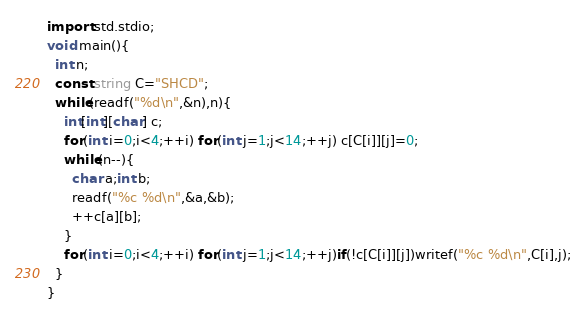Convert code to text. <code><loc_0><loc_0><loc_500><loc_500><_D_>import std.stdio;
void main(){
  int n;
  const string C="SHCD";
  while(readf("%d\n",&n),n){
    int[int][char] c;
    for(int i=0;i<4;++i) for(int j=1;j<14;++j) c[C[i]][j]=0;
    while(n--){
      char a;int b;
      readf("%c %d\n",&a,&b);
      ++c[a][b];
    }
    for(int i=0;i<4;++i) for(int j=1;j<14;++j)if(!c[C[i]][j])writef("%c %d\n",C[i],j);
  }
}</code> 